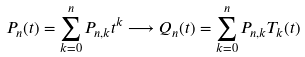<formula> <loc_0><loc_0><loc_500><loc_500>P _ { n } ( t ) = \sum _ { k = 0 } ^ { n } P _ { n , k } t ^ { k } \longrightarrow Q _ { n } ( t ) = \sum _ { k = 0 } ^ { n } P _ { n , k } T _ { k } ( t )</formula> 